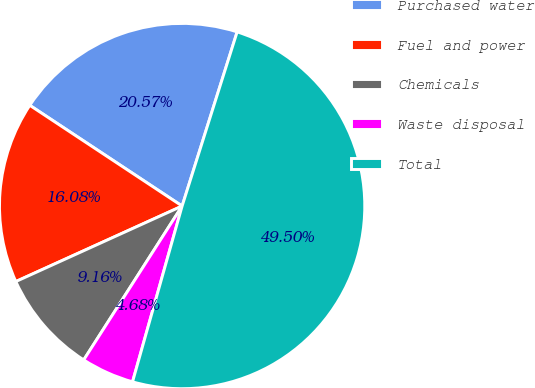Convert chart to OTSL. <chart><loc_0><loc_0><loc_500><loc_500><pie_chart><fcel>Purchased water<fcel>Fuel and power<fcel>Chemicals<fcel>Waste disposal<fcel>Total<nl><fcel>20.57%<fcel>16.08%<fcel>9.16%<fcel>4.68%<fcel>49.5%<nl></chart> 